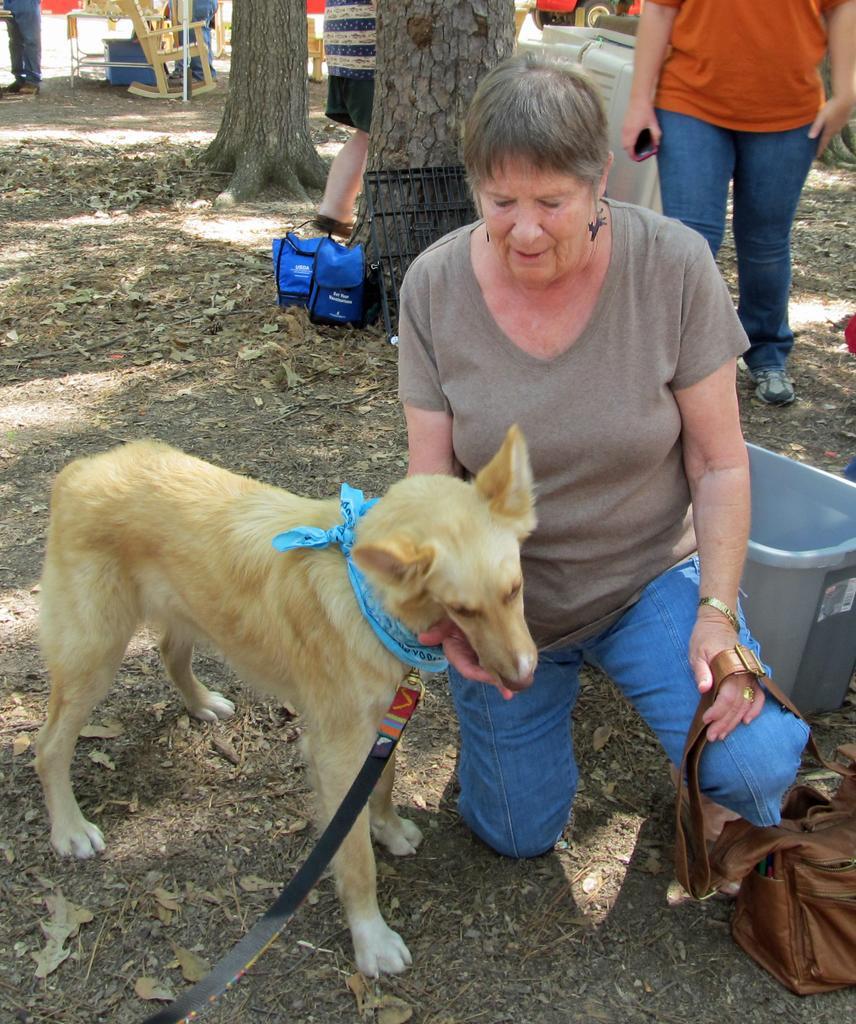Could you give a brief overview of what you see in this image? This is the picture in the outdoor, this is a dog which is tied with a belt and beside the dog there is women siting and watching the dong and the women is holding a bag beside the women there is a container and there is other person who is in orange T shirt and blue jeans and the background of the women there is a trees and there is chair. 